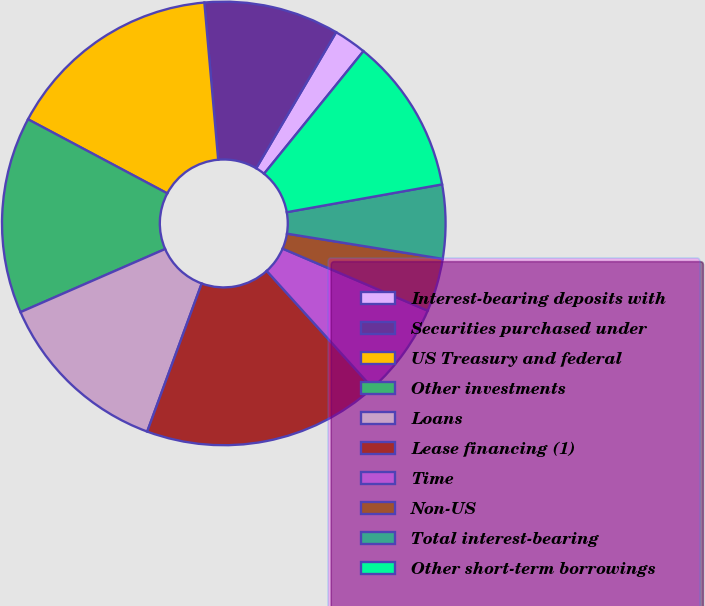<chart> <loc_0><loc_0><loc_500><loc_500><pie_chart><fcel>Interest-bearing deposits with<fcel>Securities purchased under<fcel>US Treasury and federal<fcel>Other investments<fcel>Loans<fcel>Lease financing (1)<fcel>Time<fcel>Non-US<fcel>Total interest-bearing<fcel>Other short-term borrowings<nl><fcel>2.39%<fcel>9.85%<fcel>15.82%<fcel>14.33%<fcel>12.84%<fcel>17.31%<fcel>6.87%<fcel>3.88%<fcel>5.37%<fcel>11.34%<nl></chart> 